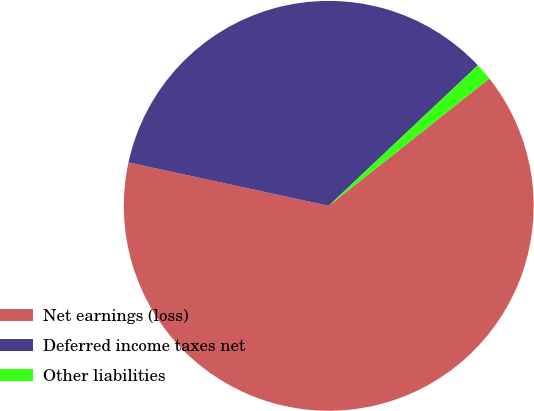<chart> <loc_0><loc_0><loc_500><loc_500><pie_chart><fcel>Net earnings (loss)<fcel>Deferred income taxes net<fcel>Other liabilities<nl><fcel>64.07%<fcel>34.58%<fcel>1.36%<nl></chart> 